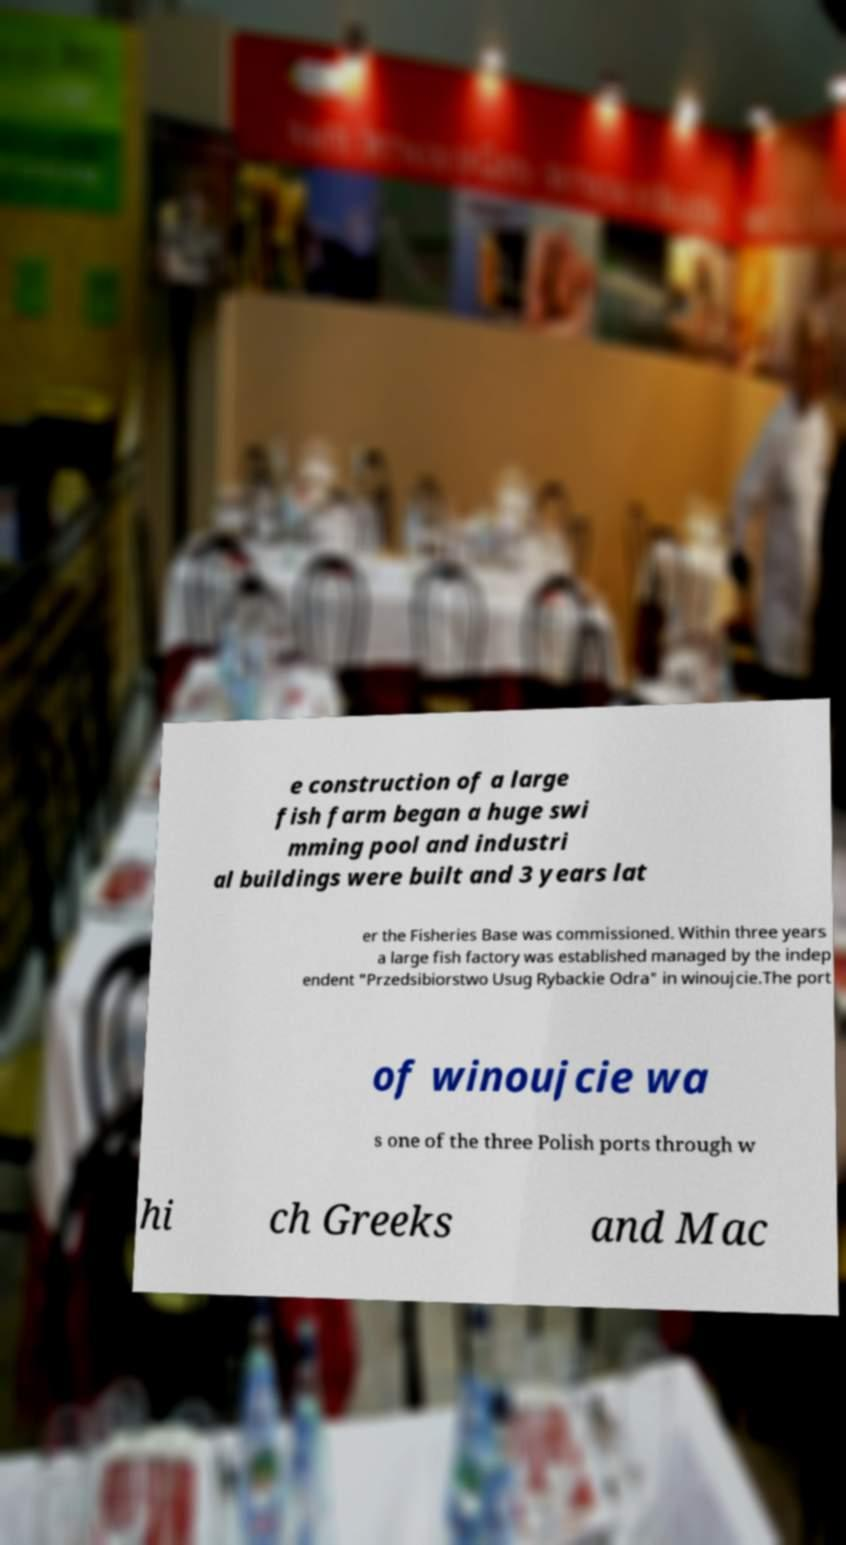Could you extract and type out the text from this image? e construction of a large fish farm began a huge swi mming pool and industri al buildings were built and 3 years lat er the Fisheries Base was commissioned. Within three years a large fish factory was established managed by the indep endent "Przedsibiorstwo Usug Rybackie Odra" in winoujcie.The port of winoujcie wa s one of the three Polish ports through w hi ch Greeks and Mac 